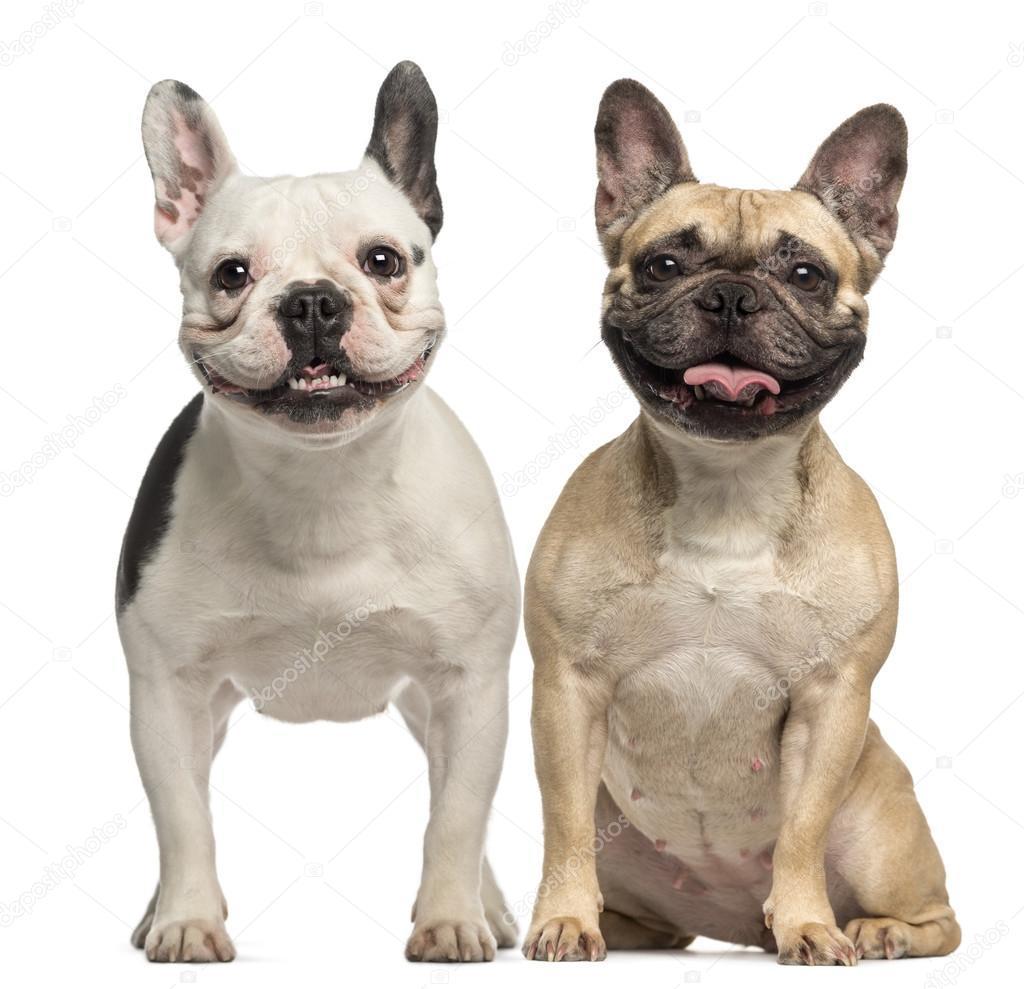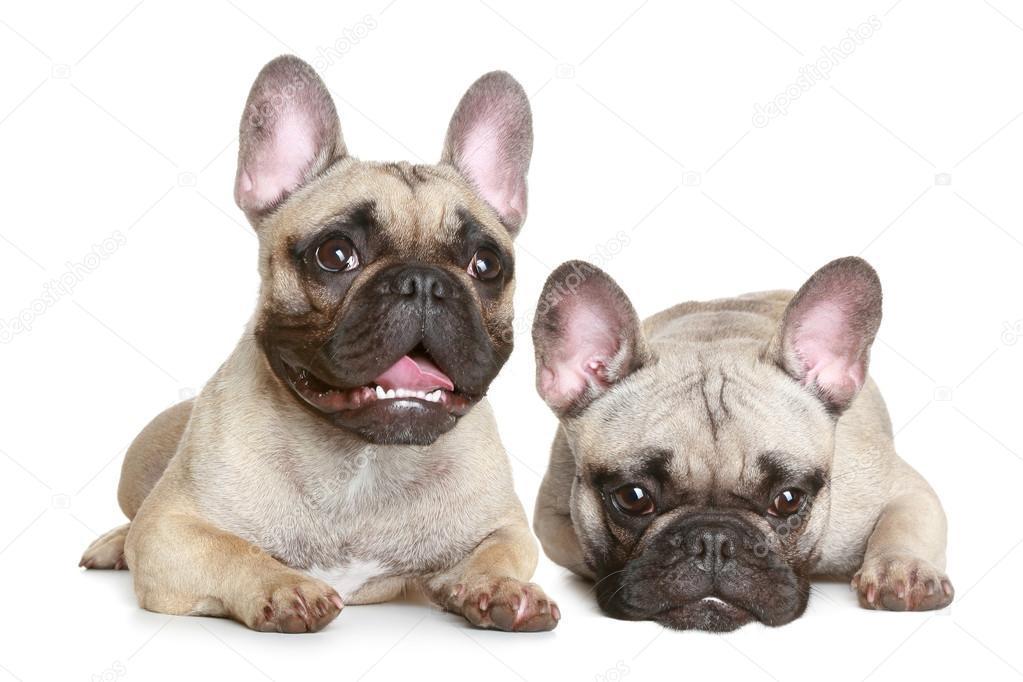The first image is the image on the left, the second image is the image on the right. Given the left and right images, does the statement "In one image, two dogs are touching one another, with at least one of the dogs touching the other with its mouth" hold true? Answer yes or no. No. The first image is the image on the left, the second image is the image on the right. Considering the images on both sides, is "Left image shows side-by-side dogs, with at least one dog sitting upright." valid? Answer yes or no. Yes. 